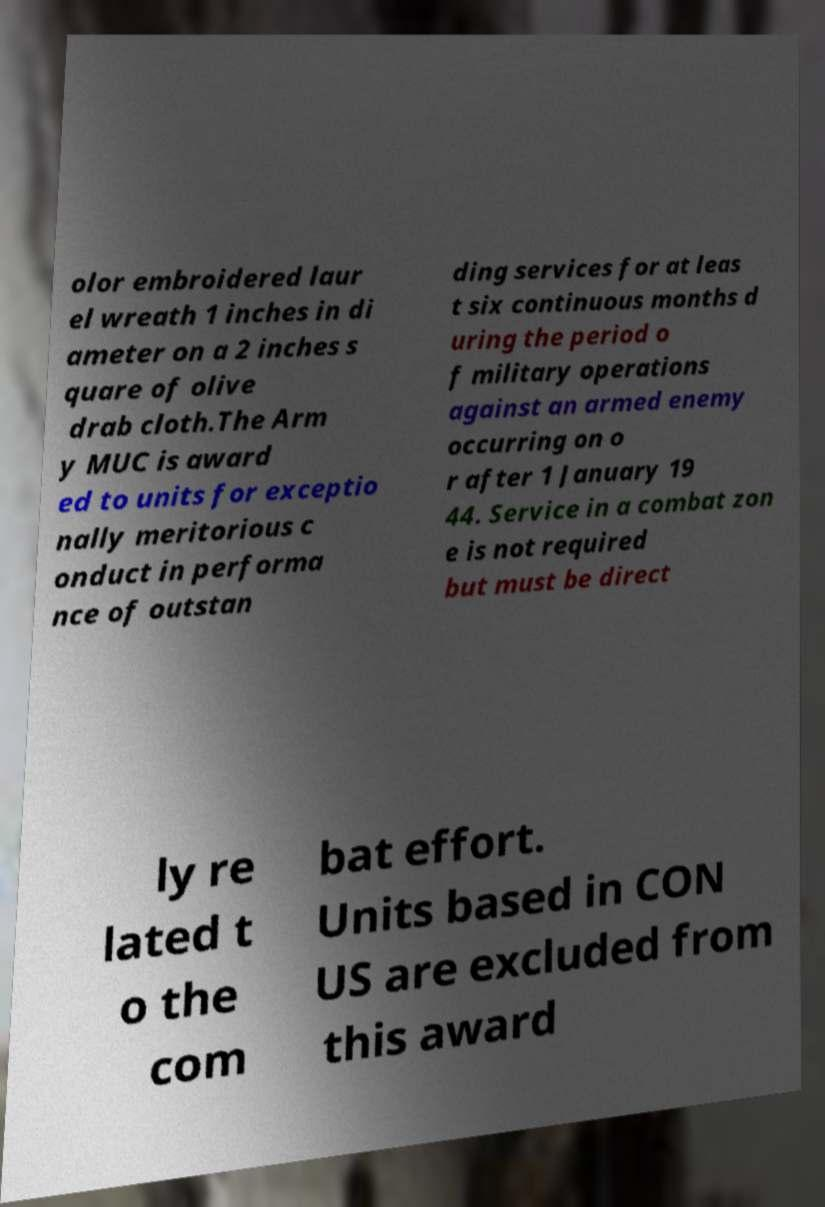Please read and relay the text visible in this image. What does it say? olor embroidered laur el wreath 1 inches in di ameter on a 2 inches s quare of olive drab cloth.The Arm y MUC is award ed to units for exceptio nally meritorious c onduct in performa nce of outstan ding services for at leas t six continuous months d uring the period o f military operations against an armed enemy occurring on o r after 1 January 19 44. Service in a combat zon e is not required but must be direct ly re lated t o the com bat effort. Units based in CON US are excluded from this award 